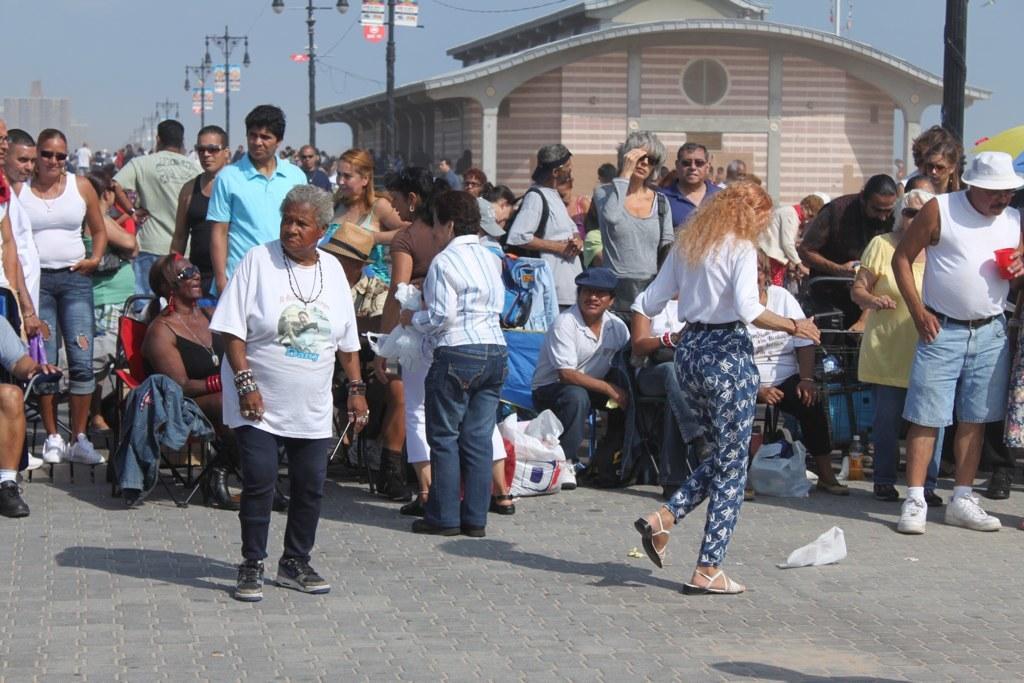Describe this image in one or two sentences. In this image, we can see a group of people. Few are standing sitting and walking on the path. Here we can see few objects, bottle, carry bags and things. Background we can see street lights, poles, banners, house, wall and sky. 